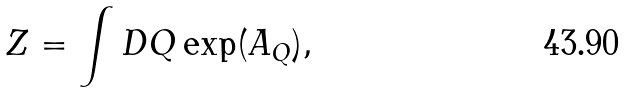Convert formula to latex. <formula><loc_0><loc_0><loc_500><loc_500>Z = \int D Q \exp ( A _ { Q } ) ,</formula> 